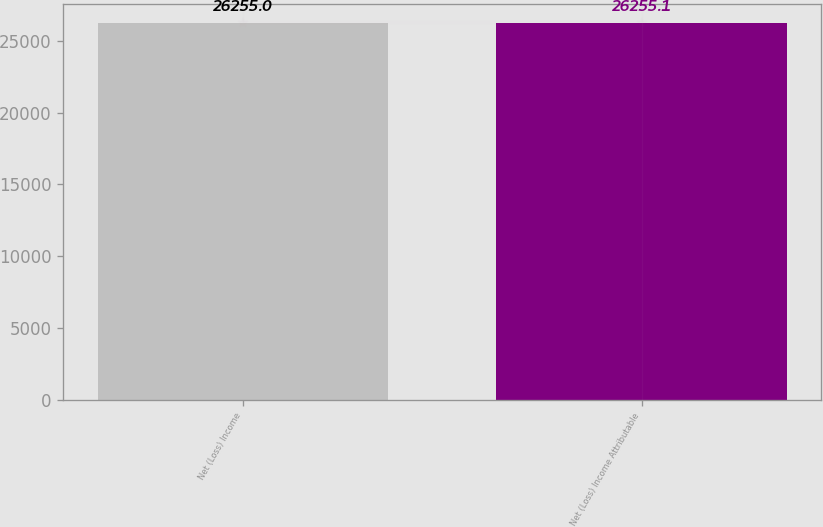Convert chart to OTSL. <chart><loc_0><loc_0><loc_500><loc_500><bar_chart><fcel>Net (Loss) Income<fcel>Net (Loss) Income Attributable<nl><fcel>26255<fcel>26255.1<nl></chart> 